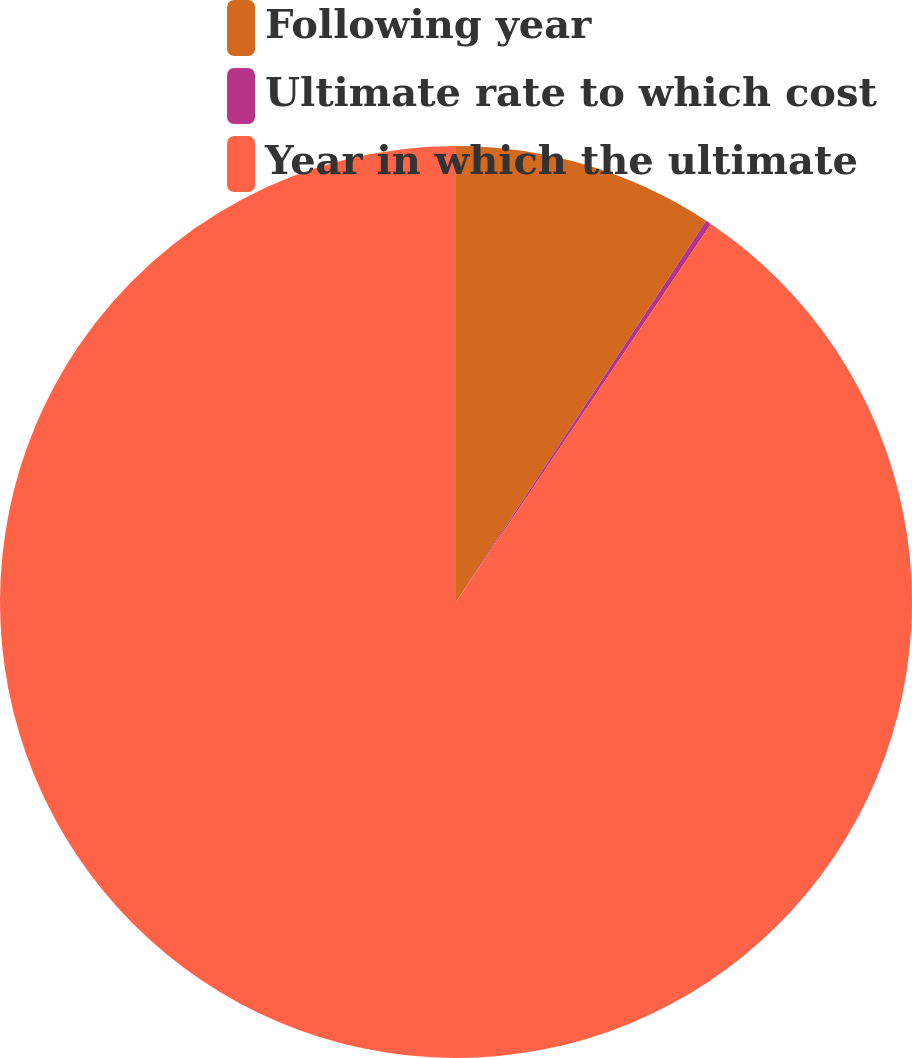Convert chart. <chart><loc_0><loc_0><loc_500><loc_500><pie_chart><fcel>Following year<fcel>Ultimate rate to which cost<fcel>Year in which the ultimate<nl><fcel>9.24%<fcel>0.2%<fcel>90.56%<nl></chart> 